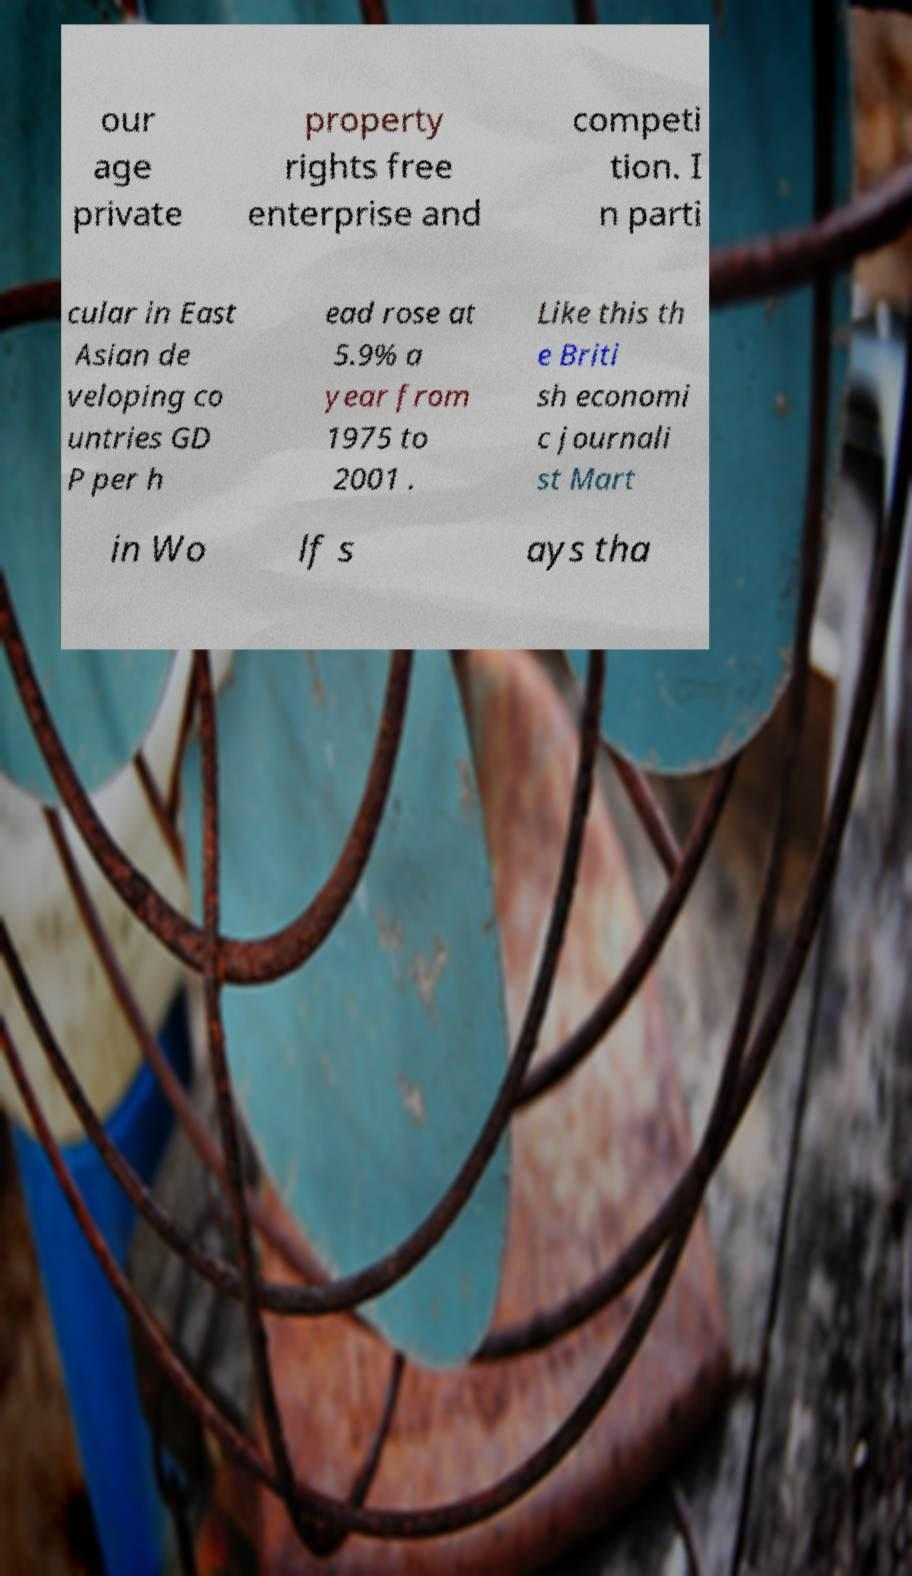Can you accurately transcribe the text from the provided image for me? our age private property rights free enterprise and competi tion. I n parti cular in East Asian de veloping co untries GD P per h ead rose at 5.9% a year from 1975 to 2001 . Like this th e Briti sh economi c journali st Mart in Wo lf s ays tha 